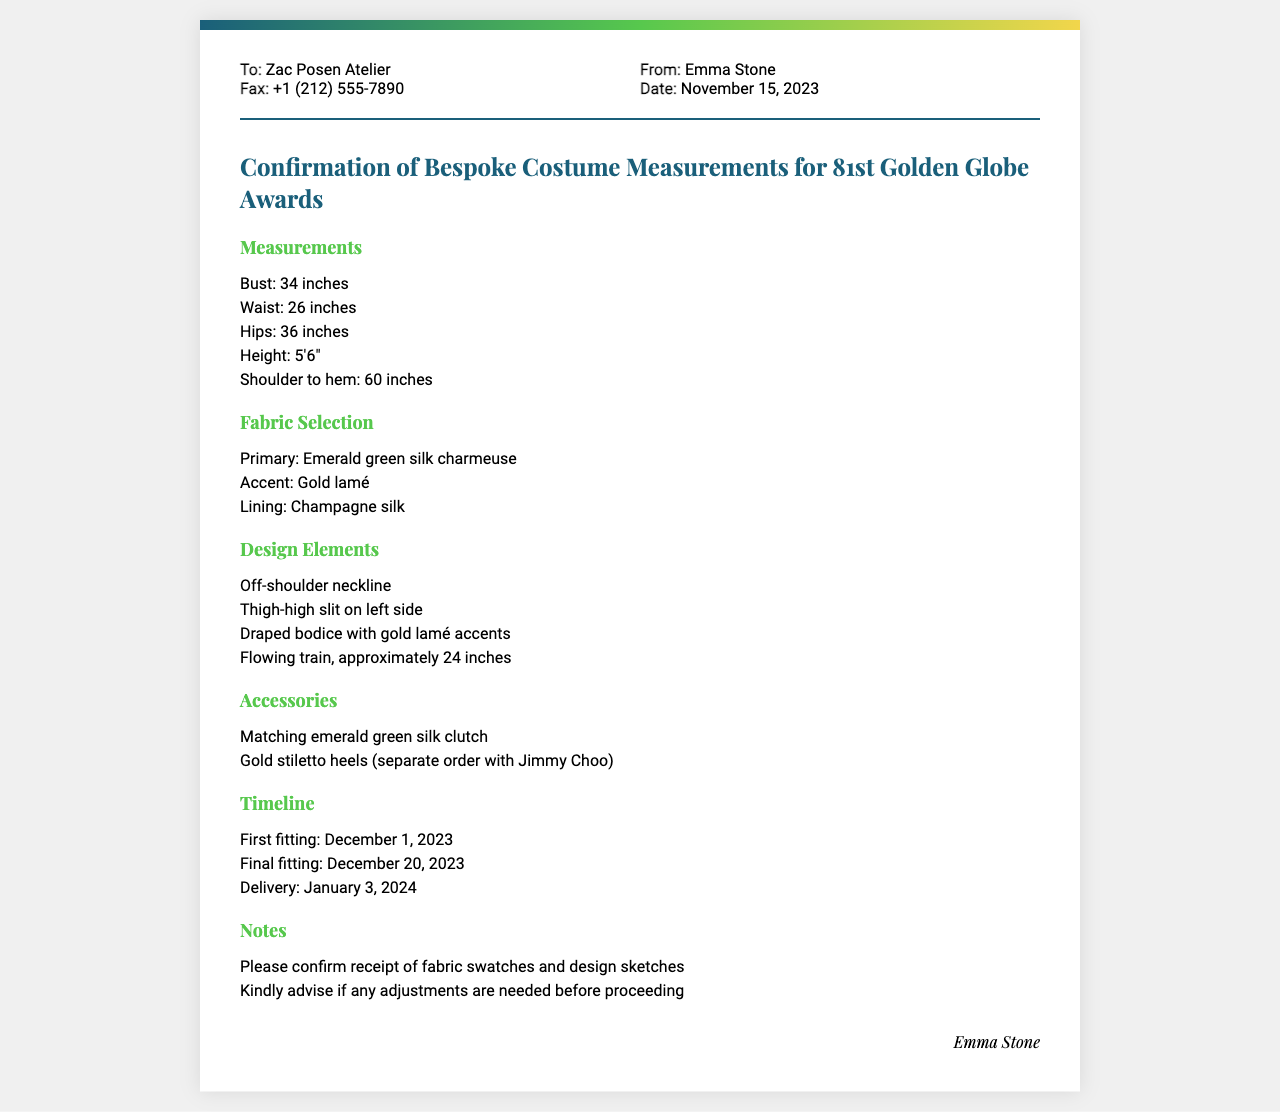What is the primary fabric selected for the costume? The primary fabric selected for the costume is listed in the fabric selection section of the document.
Answer: Emerald green silk charmeuse What is the date of the first fitting? The date for the first fitting is found in the timeline section of the document.
Answer: December 1, 2023 What type of neckline is featured in the design? The type of neckline can be found in the design elements section of the document.
Answer: Off-shoulder neckline How tall is the actor? Height is mentioned under the measurements section of the document.
Answer: 5'6" What is the delivery date for the costume? The delivery date is provided in the timeline section of the document.
Answer: January 3, 2024 What is the accent fabric for the costume? The accent fabric can be found in the fabric selection section of the document.
Answer: Gold lamé What is requested in the notes section? The notes section of the document contains specific requests.
Answer: Confirm receipt of fabric swatches and design sketches What feature does the costume have on the left side? The design elements section describes specific features of the costume.
Answer: Thigh-high slit 